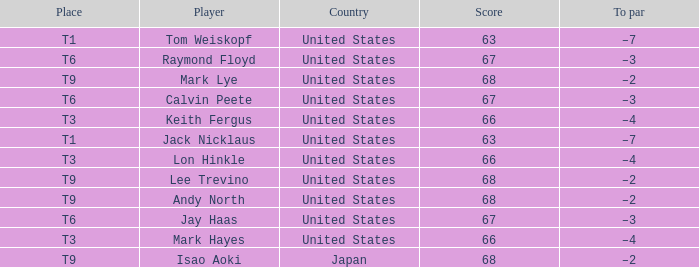What is the Country, when Place is T6, and when Player is "Raymond Floyd"? United States. Would you mind parsing the complete table? {'header': ['Place', 'Player', 'Country', 'Score', 'To par'], 'rows': [['T1', 'Tom Weiskopf', 'United States', '63', '–7'], ['T6', 'Raymond Floyd', 'United States', '67', '–3'], ['T9', 'Mark Lye', 'United States', '68', '–2'], ['T6', 'Calvin Peete', 'United States', '67', '–3'], ['T3', 'Keith Fergus', 'United States', '66', '–4'], ['T1', 'Jack Nicklaus', 'United States', '63', '–7'], ['T3', 'Lon Hinkle', 'United States', '66', '–4'], ['T9', 'Lee Trevino', 'United States', '68', '–2'], ['T9', 'Andy North', 'United States', '68', '–2'], ['T6', 'Jay Haas', 'United States', '67', '–3'], ['T3', 'Mark Hayes', 'United States', '66', '–4'], ['T9', 'Isao Aoki', 'Japan', '68', '–2']]} 